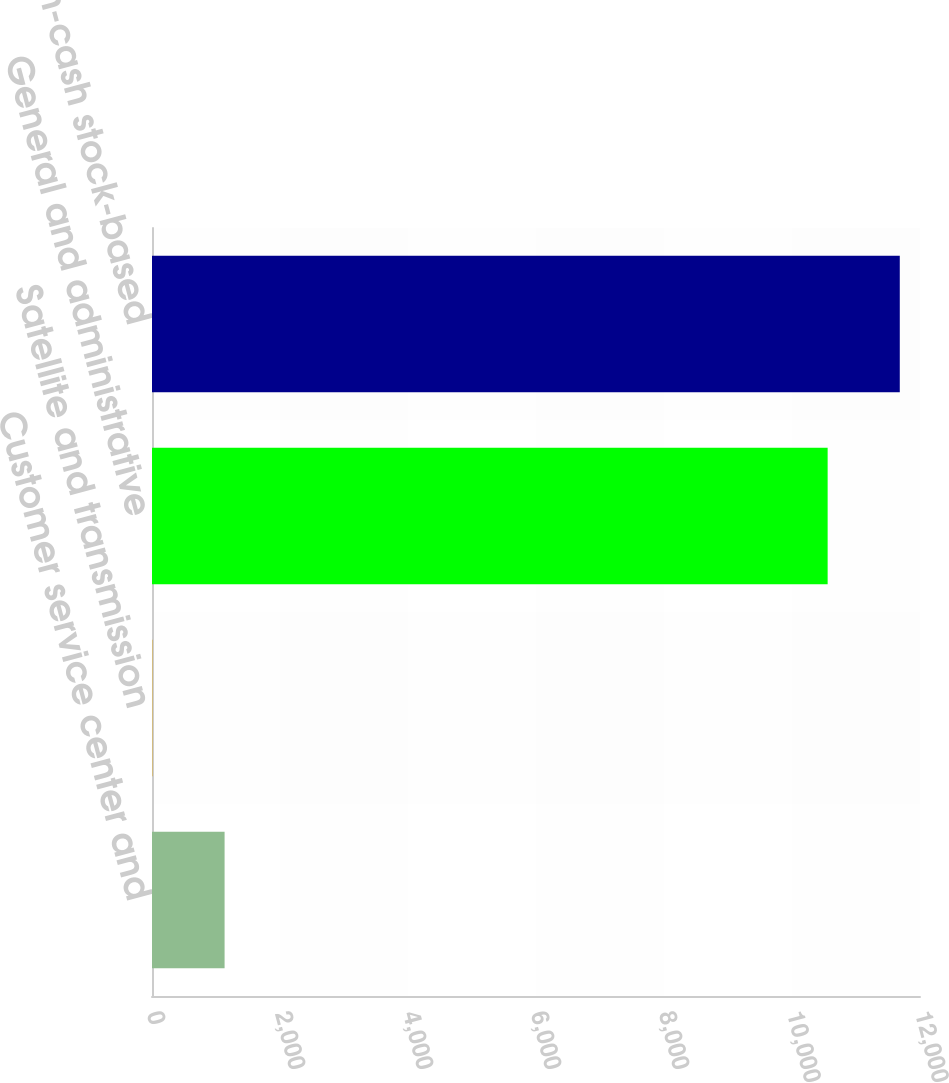Convert chart. <chart><loc_0><loc_0><loc_500><loc_500><bar_chart><fcel>Customer service center and<fcel>Satellite and transmission<fcel>General and administrative<fcel>Total non-cash stock-based<nl><fcel>1134.2<fcel>7<fcel>10557<fcel>11684.2<nl></chart> 